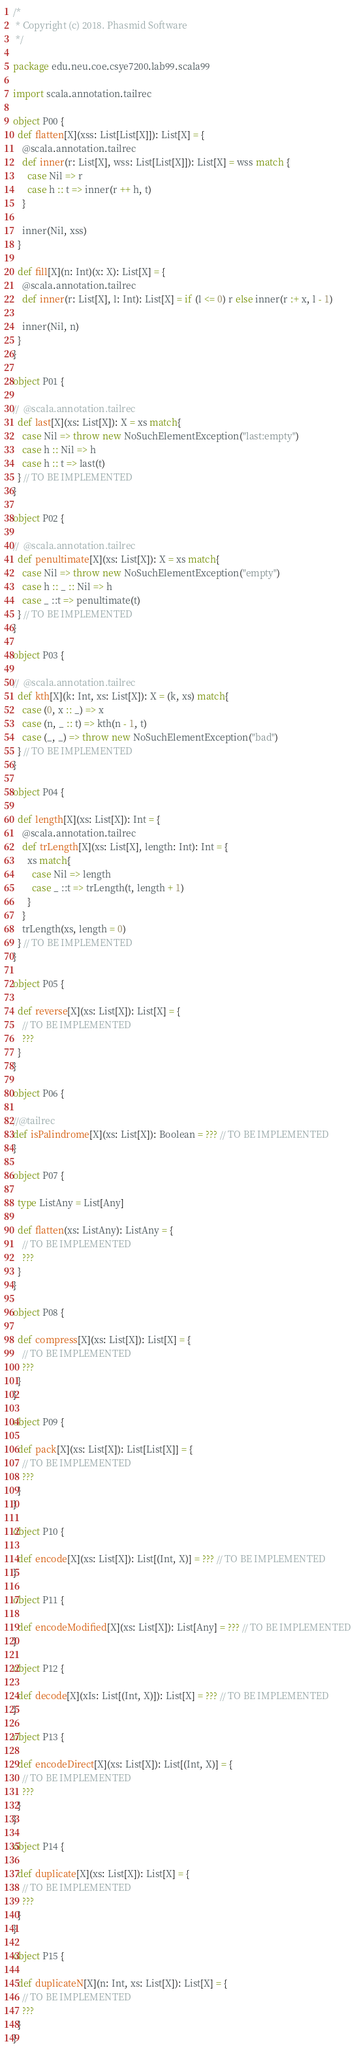<code> <loc_0><loc_0><loc_500><loc_500><_Scala_>/*
 * Copyright (c) 2018. Phasmid Software
 */

package edu.neu.coe.csye7200.lab99.scala99

import scala.annotation.tailrec

object P00 {
  def flatten[X](xss: List[List[X]]): List[X] = {
    @scala.annotation.tailrec
    def inner(r: List[X], wss: List[List[X]]): List[X] = wss match {
      case Nil => r
      case h :: t => inner(r ++ h, t)
    }

    inner(Nil, xss)
  }

  def fill[X](n: Int)(x: X): List[X] = {
    @scala.annotation.tailrec
    def inner(r: List[X], l: Int): List[X] = if (l <= 0) r else inner(r :+ x, l - 1)

    inner(Nil, n)
  }
}

object P01 {

//  @scala.annotation.tailrec
  def last[X](xs: List[X]): X = xs match{
    case Nil => throw new NoSuchElementException("last:empty")
    case h :: Nil => h
    case h :: t => last(t)
  } // TO BE IMPLEMENTED
}

object P02 {

//  @scala.annotation.tailrec
  def penultimate[X](xs: List[X]): X = xs match{
    case Nil => throw new NoSuchElementException("empty")
    case h :: _ :: Nil => h
    case _ ::t => penultimate(t)
  } // TO BE IMPLEMENTED
}

object P03 {

//  @scala.annotation.tailrec
  def kth[X](k: Int, xs: List[X]): X = (k, xs) match{
    case (0, x :: _) => x
    case (n, _ :: t) => kth(n - 1, t)
    case (_, _) => throw new NoSuchElementException("bad")
  } // TO BE IMPLEMENTED
}

object P04 {

  def length[X](xs: List[X]): Int = {
    @scala.annotation.tailrec
    def trLength[X](xs: List[X], length: Int): Int = {
      xs match{
        case Nil => length
        case _ ::t => trLength(t, length + 1)
      }
    }
    trLength(xs, length = 0)
  } // TO BE IMPLEMENTED
}

object P05 {

  def reverse[X](xs: List[X]): List[X] = {
    // TO BE IMPLEMENTED
    ???
  }
}

object P06 {

//@tailrec
def isPalindrome[X](xs: List[X]): Boolean = ??? // TO BE IMPLEMENTED
}

object P07 {

  type ListAny = List[Any]

  def flatten(xs: ListAny): ListAny = {
    // TO BE IMPLEMENTED
    ???
  }
}

object P08 {

  def compress[X](xs: List[X]): List[X] = {
    // TO BE IMPLEMENTED
    ???
  }
}

object P09 {

  def pack[X](xs: List[X]): List[List[X]] = {
    // TO BE IMPLEMENTED
    ???
  }
}

object P10 {

  def encode[X](xs: List[X]): List[(Int, X)] = ??? // TO BE IMPLEMENTED
}

object P11 {

  def encodeModified[X](xs: List[X]): List[Any] = ??? // TO BE IMPLEMENTED
}

object P12 {

  def decode[X](xIs: List[(Int, X)]): List[X] = ??? // TO BE IMPLEMENTED
}

object P13 {

  def encodeDirect[X](xs: List[X]): List[(Int, X)] = {
    // TO BE IMPLEMENTED
    ???
  }
}

object P14 {

  def duplicate[X](xs: List[X]): List[X] = {
    // TO BE IMPLEMENTED
    ???
  }
}

object P15 {

  def duplicateN[X](n: Int, xs: List[X]): List[X] = {
    // TO BE IMPLEMENTED
    ???
  }
}
</code> 